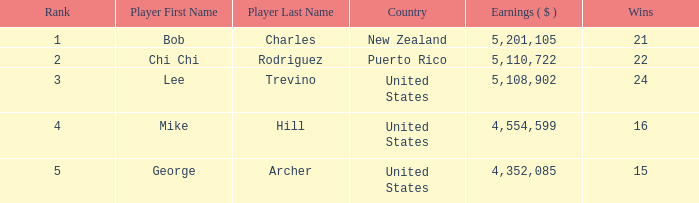On average, how many wins have a rank lower than 1? None. 